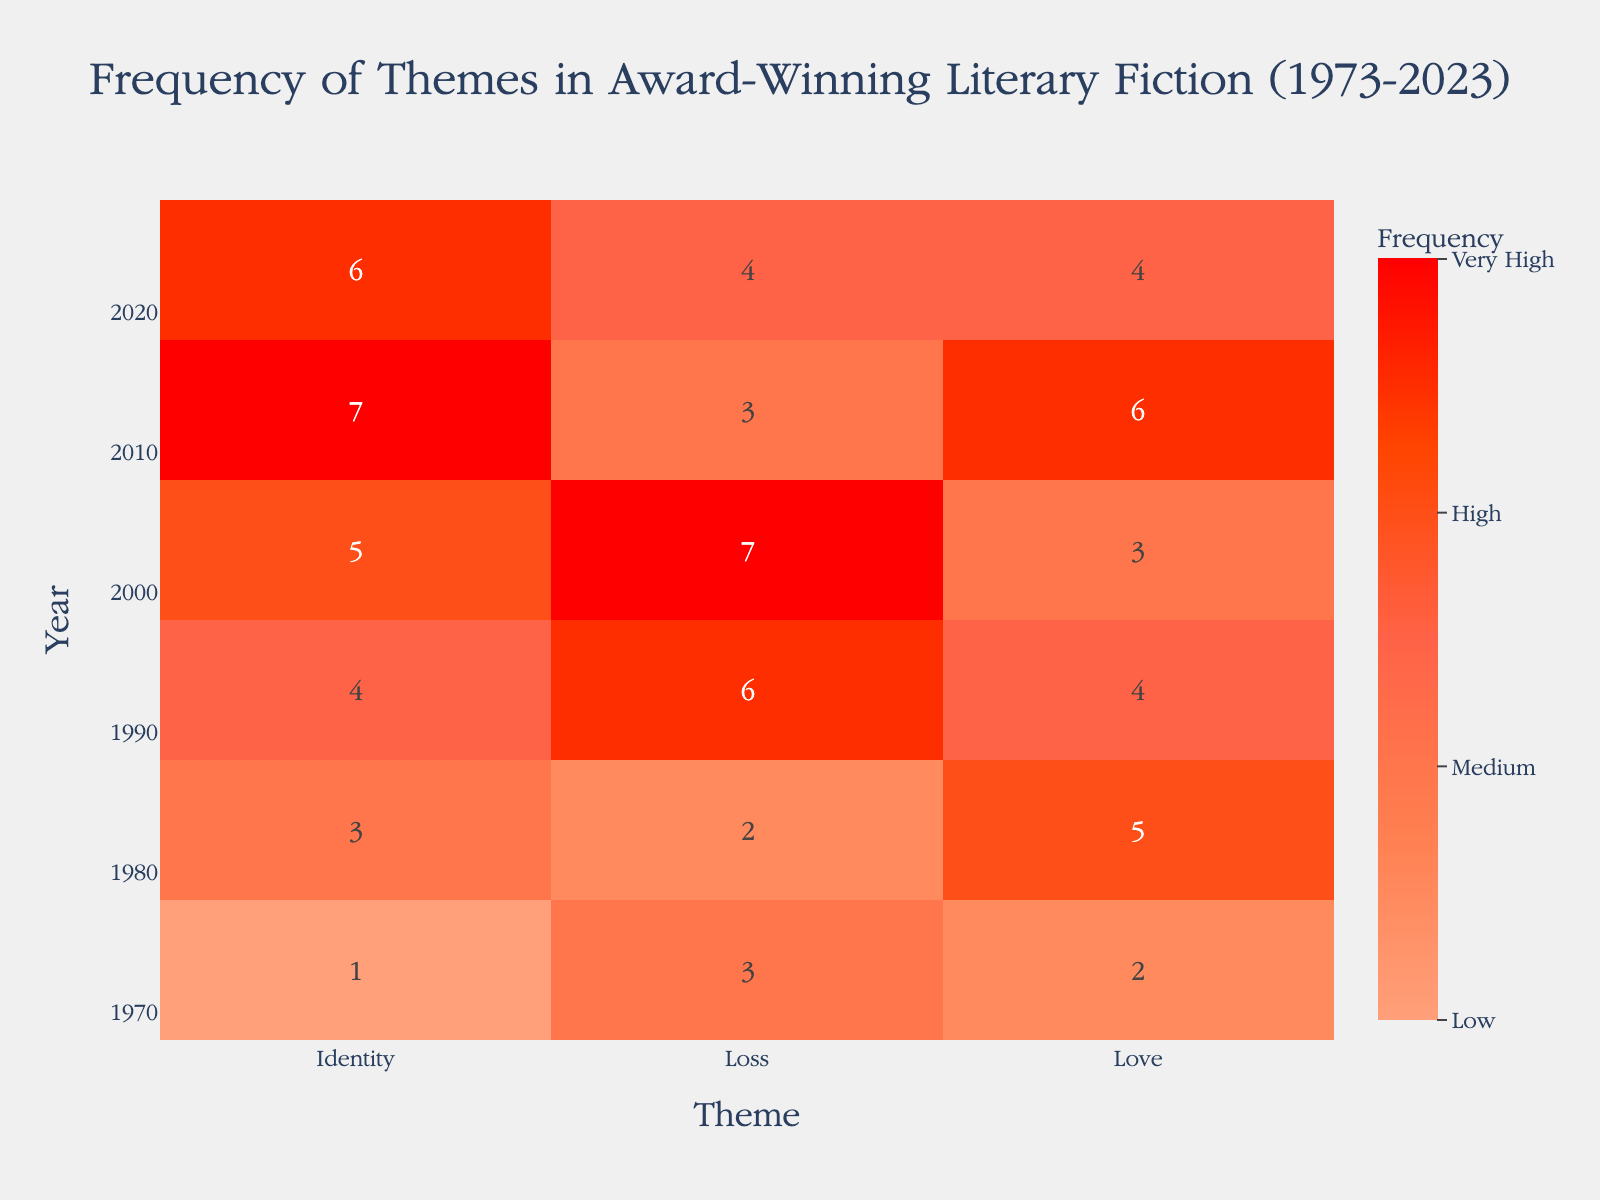What's the title of the heatmap? The title of a heatmap is often displayed prominently at the top center of the figure. From the description, the title of the heatmap is "Frequency of Themes in Award-Winning Literary Fiction (1973-2023)"
Answer: Frequency of Themes in Award-Winning Literary Fiction (1973-2023) What themes are represented on the x-axis? The x-axis in a heatmap typically displays different categories, in this case, the themes. From the provided data, the themes represented are Love, Loss, and Identity
Answer: Love, Loss, and Identity In which year did "Loss" have the highest frequency? To determine this, look at the cells under the "Loss" theme and find the one with the highest count. Based on the data, the year with the highest frequency for "Loss" is 2003 with a count of 7
Answer: 2003 How many times did "Identity" occur in 2023? Locate the cell where the year is 2023 and the theme is "Identity," and read off the count. The heatmap shows that the count is 6
Answer: 6 How does the frequency of "Love" in 1983 compare to 2003? Compare the counts for "Love" in these two years. In 1983, the frequency is 5, while in 2003, it is 3. So, the frequency of "Love" is higher in 1983 than in 2003
Answer: Higher in 1983 What was the average frequency of the theme "Identity" over the years? To find this, sum the frequencies for “Identity” over all the years and divide by the number of years. The counts are [1, 3, 4, 5, 7, 6]. Sum them to get 26, then divide by 6 (the number of years). Therefore, the average is 26 / 6 ≈ 4.33
Answer: 4.33 Which theme had the lowest frequency in 2013? Look at the cells for the year 2013 and identify the smallest count. The counts are Love: 6, Loss: 3, and Identity: 7. Thus, "Loss" had the lowest frequency in 2013
Answer: Loss What is the median frequency of "Loss" across all years? First, list the frequencies of "Loss" for each year: [3, 2, 6, 7, 3, 4]. Then, sort these values: [2, 3, 3, 4, 6, 7]. The median is the average of the middle two numbers in a sorted list, which are 3 and 4. So, (3 + 4) / 2 = 3.5
Answer: 3.5 In which year did all themes have their frequency in the range of 3 to 6? Check the counts for each year to see if all themes fall within 3 and 6. The year 2023 has frequencies Love: 4, Loss: 4, Identity: 6, all of which are within this range
Answer: 2023 